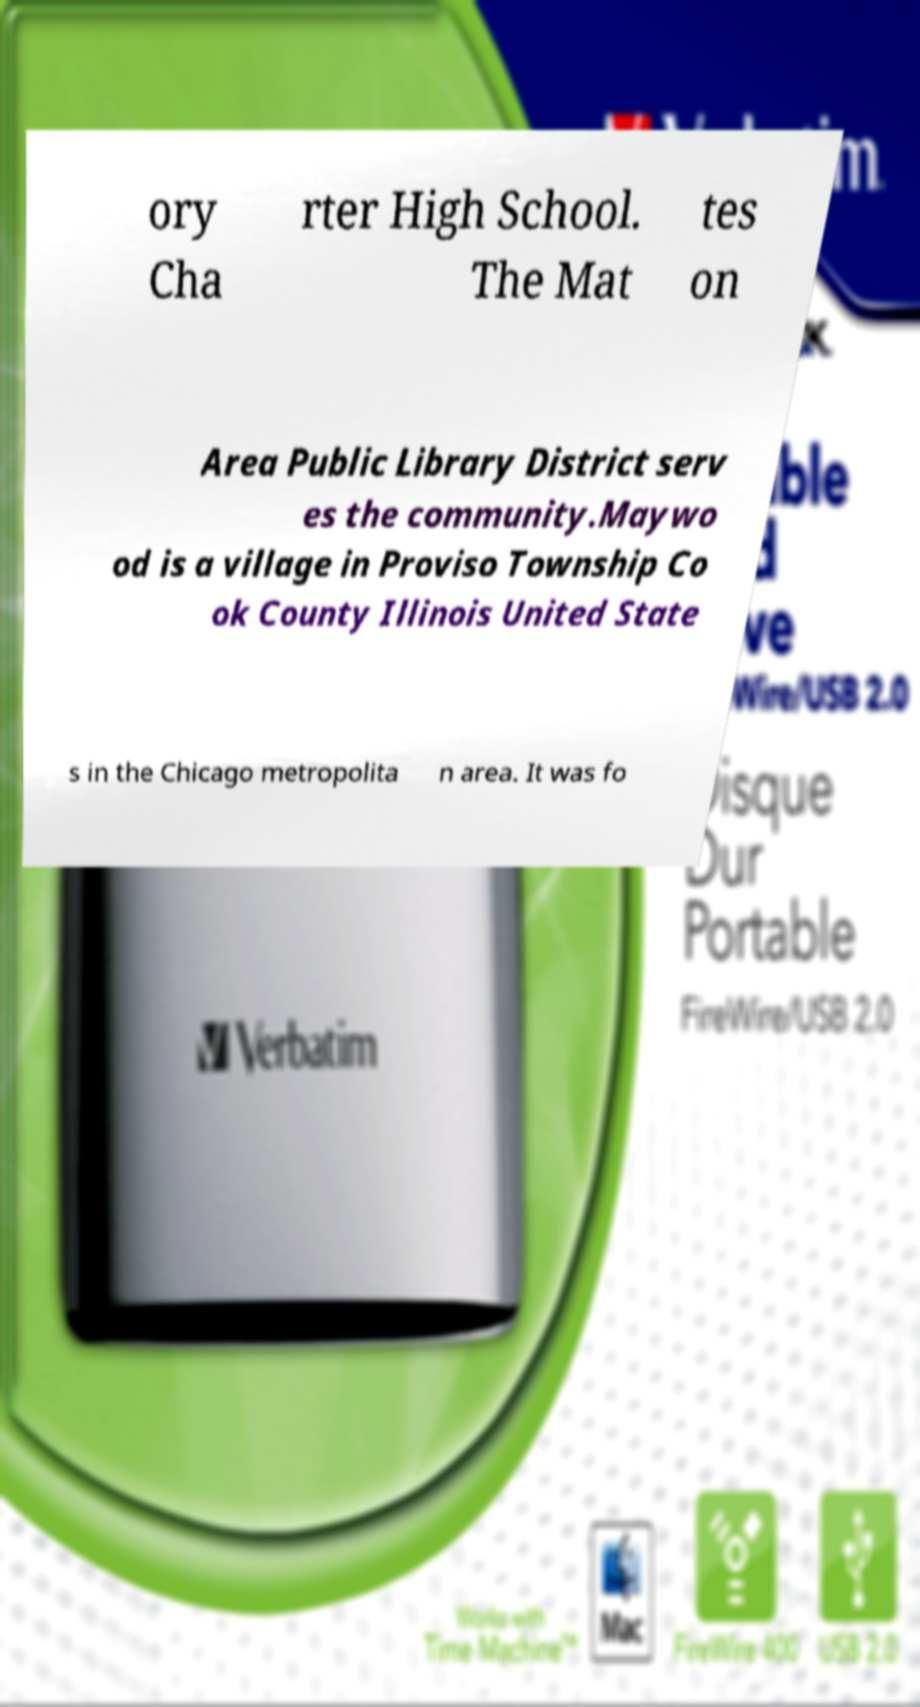Please read and relay the text visible in this image. What does it say? ory Cha rter High School. The Mat tes on Area Public Library District serv es the community.Maywo od is a village in Proviso Township Co ok County Illinois United State s in the Chicago metropolita n area. It was fo 